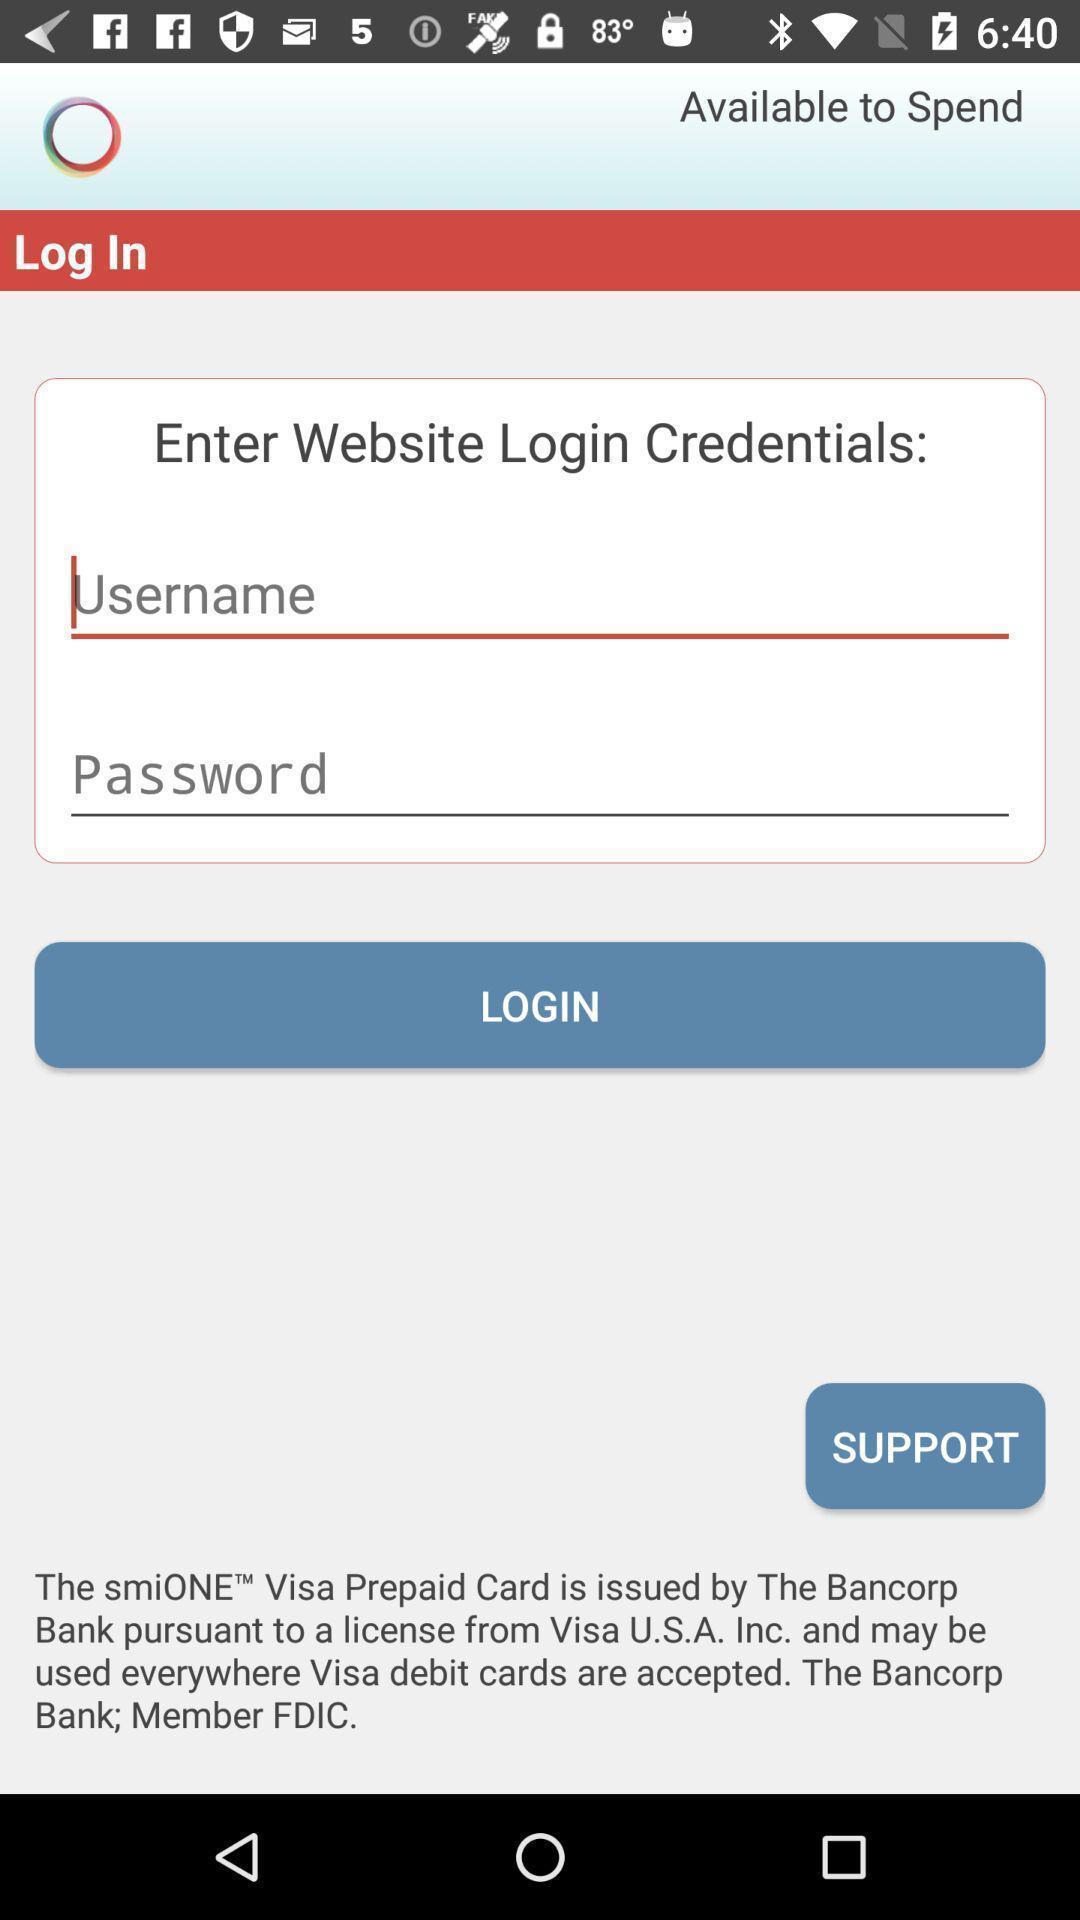Summarize the information in this screenshot. Screen displaying login page of a payment application. 